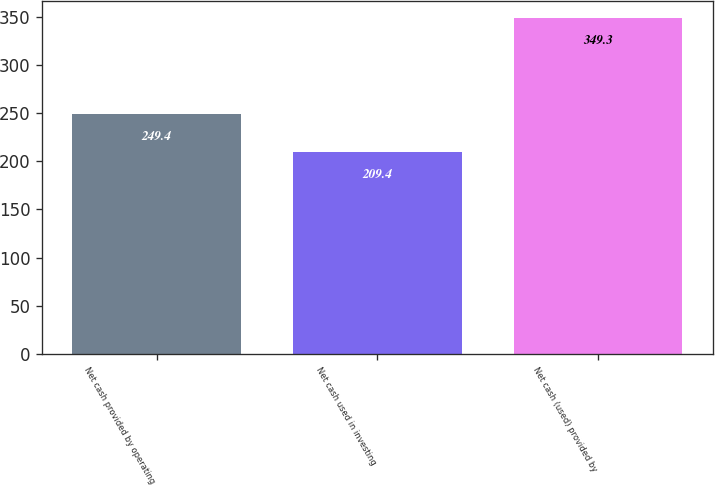Convert chart. <chart><loc_0><loc_0><loc_500><loc_500><bar_chart><fcel>Net cash provided by operating<fcel>Net cash used in investing<fcel>Net cash (used) provided by<nl><fcel>249.4<fcel>209.4<fcel>349.3<nl></chart> 